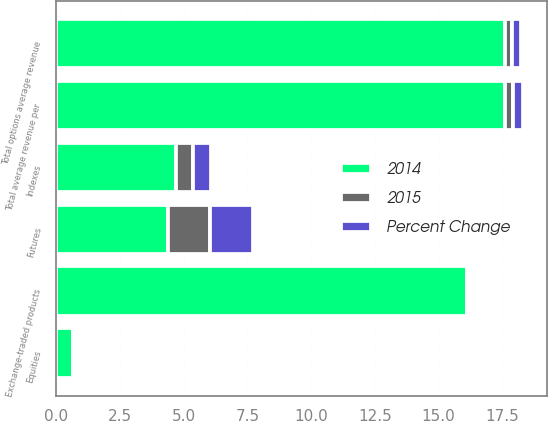Convert chart. <chart><loc_0><loc_0><loc_500><loc_500><stacked_bar_chart><ecel><fcel>Equities<fcel>Indexes<fcel>Exchange-traded products<fcel>Total options average revenue<fcel>Futures<fcel>Total average revenue per<nl><fcel>Percent Change<fcel>0.09<fcel>0.71<fcel>0.13<fcel>0.33<fcel>1.69<fcel>0.39<nl><fcel>2015<fcel>0.08<fcel>0.68<fcel>0.11<fcel>0.28<fcel>1.62<fcel>0.33<nl><fcel>2014<fcel>0.68<fcel>4.7<fcel>16.1<fcel>17.6<fcel>4.4<fcel>17.6<nl></chart> 